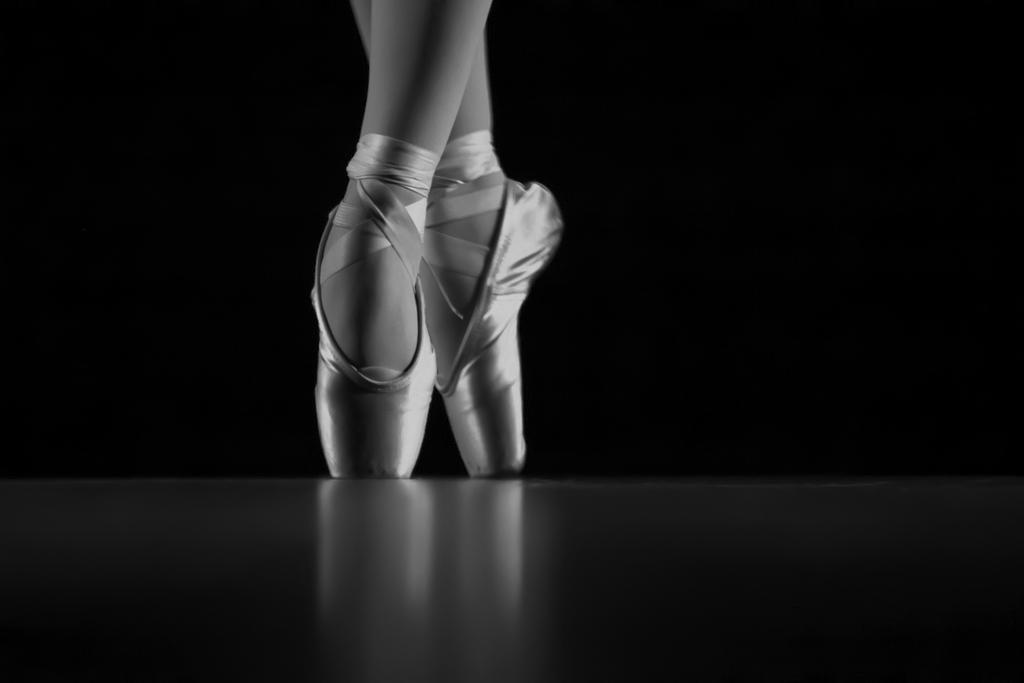What is the color scheme of the image? The image is black and white. What part of the human body can be seen in the image? There are women's legs visible in the image. Where are the legs located in the image? The legs are on the floor. What color is the background of the image? The background of the image is black. Can you see a crown on the women's legs in the image? No, there is no crown visible on the women's legs in the image. 